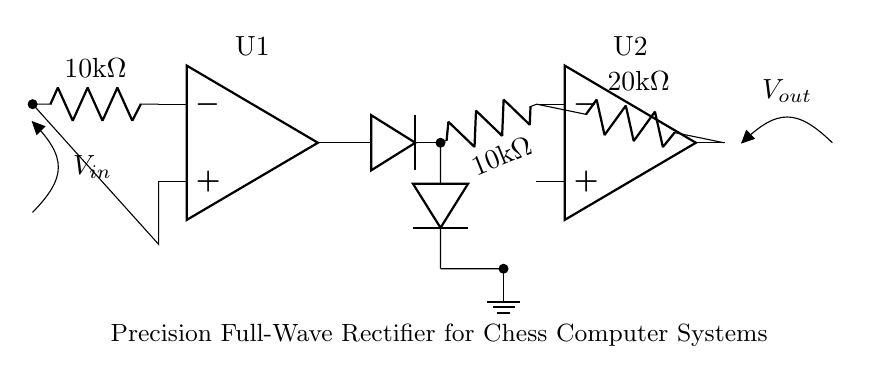What type of rectifier is shown in the circuit? The circuit is a full-wave rectifier, which is indicated by the configuration of the diodes and op-amps working together to rectify both halves of the input waveform.
Answer: Full-wave What are the resistance values of R1 and R2? The values of both R1 and R2 are shown in the circuit. R1 is labeled as 10 kilohm and R2 is also labeled as 10 kilohm, indicating their resistance values quite clearly.
Answer: 10 kilohm How many operational amplifiers are used in this circuit? The circuit diagram shows two operational amplifiers, labeled U1 and U2, indicating the total number used in the setup for processing the input signal.
Answer: 2 What is the function of the diodes in the circuit? The diodes rectify the input voltage, allowing current to flow in one direction while blocking it in the other, effectively converting alternating current into direct current.
Answer: Rectification What is the purpose of the resistor labeled Rf? The resistor Rf, which is labeled as 20 kilohm in the circuit, is used to set the feedback in the second operational amplifier, impacting the gain and ensuring accurate output from the rectifier.
Answer: Feedback gain What is the output voltage (Vout) relative to the input voltage (Vin)? The output voltage Vout is expected to be proportional to the input voltage Vin, dependent on the resistor values and the op-amp configuration, typically aiming for a precise rectification without loss.
Answer: Proportional What do the two grounds in the circuit signify? The two ground symbols indicate the reference point for the circuit, allowing all voltages to be measured relative to the same reference, crucial for accurate voltage measurements in the rectifier.
Answer: Reference point 